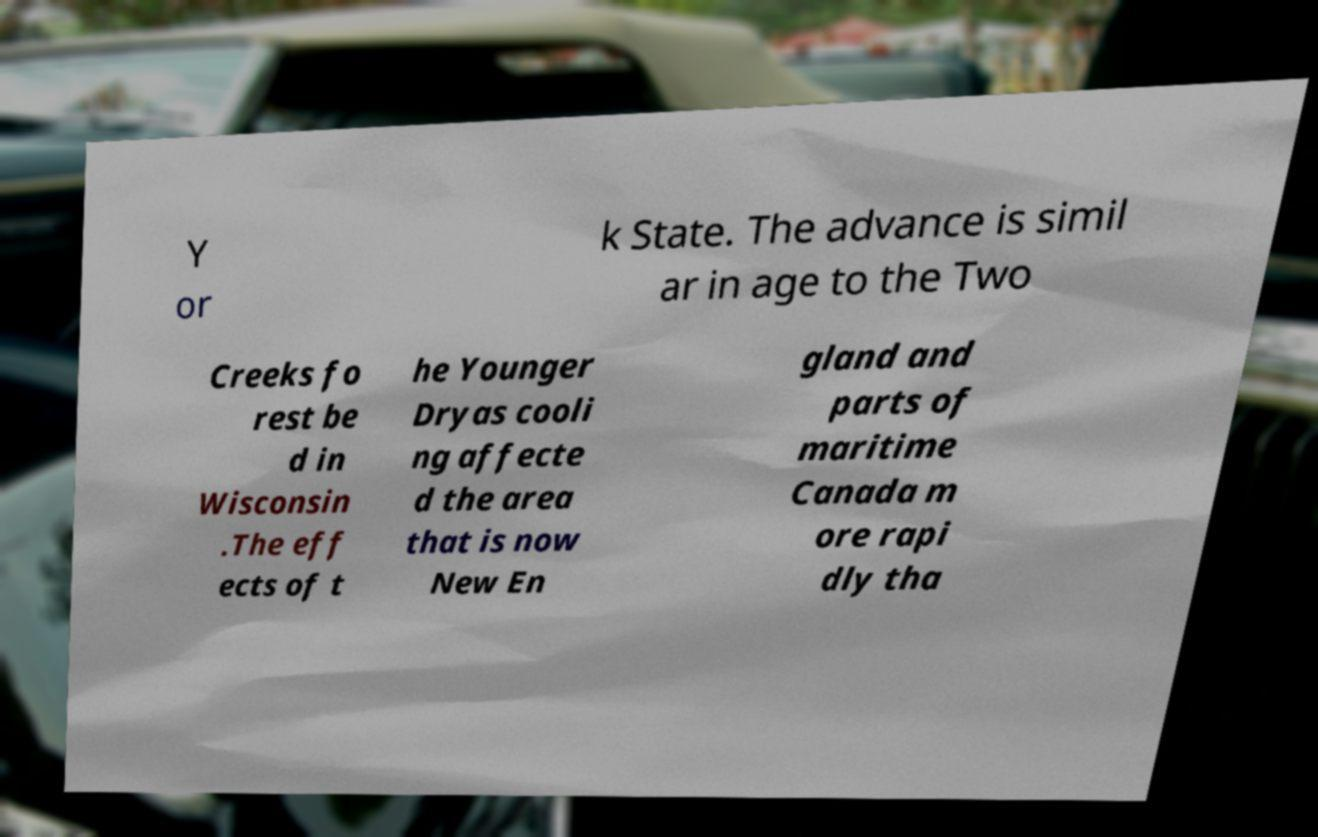Please read and relay the text visible in this image. What does it say? Y or k State. The advance is simil ar in age to the Two Creeks fo rest be d in Wisconsin .The eff ects of t he Younger Dryas cooli ng affecte d the area that is now New En gland and parts of maritime Canada m ore rapi dly tha 